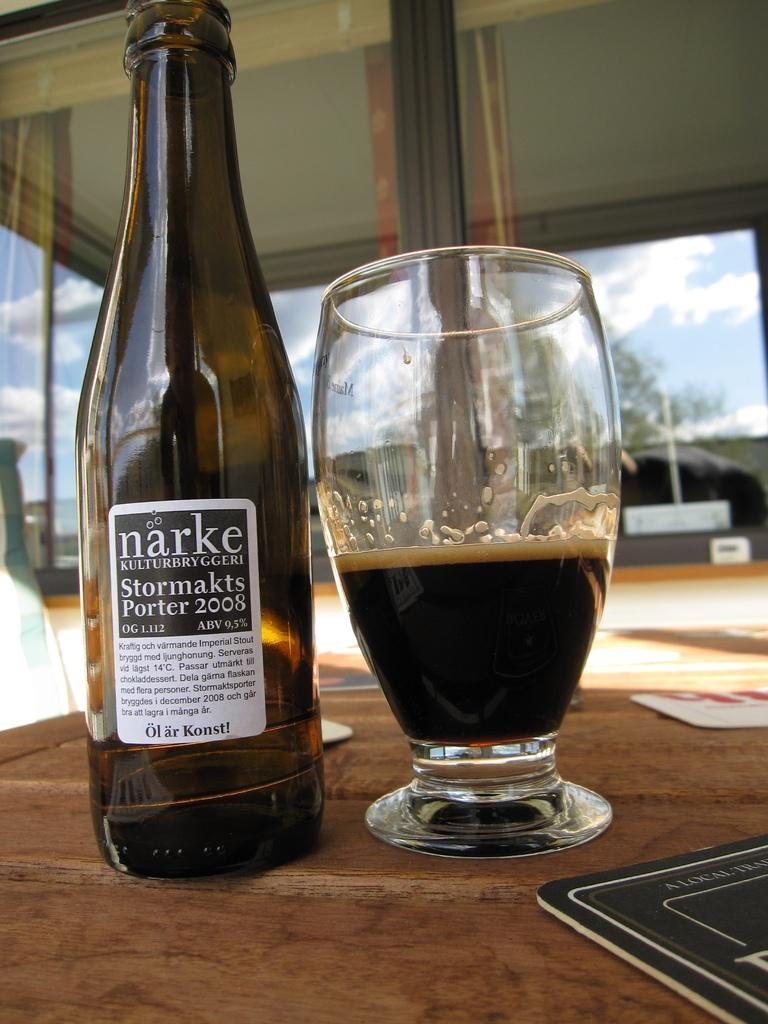<image>
Write a terse but informative summary of the picture. Bottle of Narke Stormakts porter 2008 wine and in a glass. 